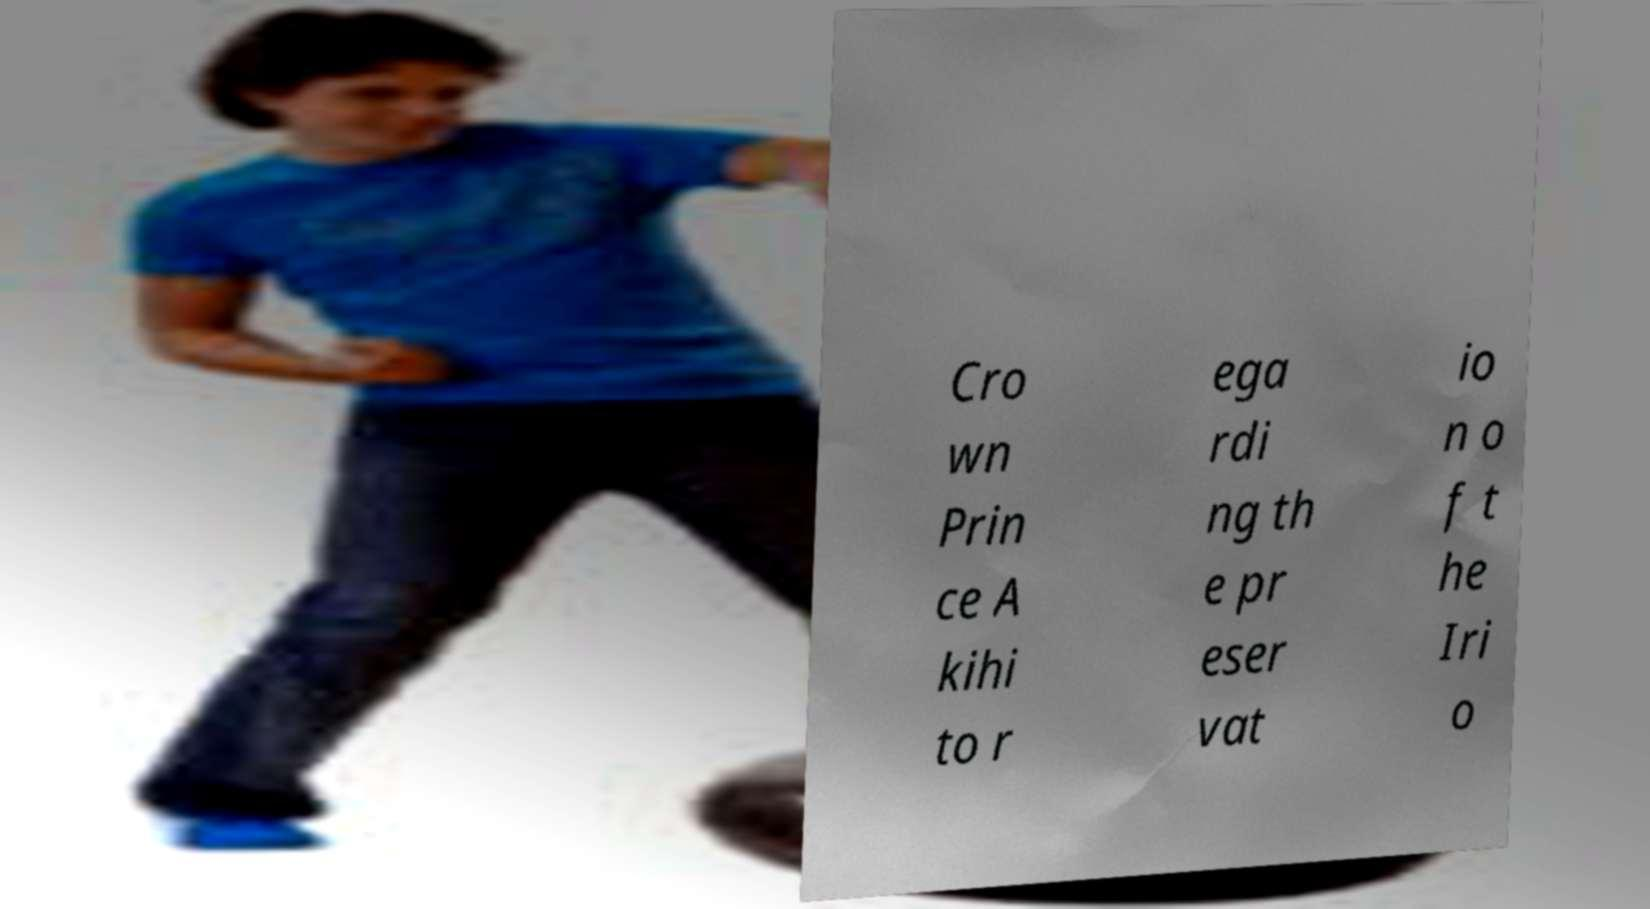Please identify and transcribe the text found in this image. Cro wn Prin ce A kihi to r ega rdi ng th e pr eser vat io n o f t he Iri o 